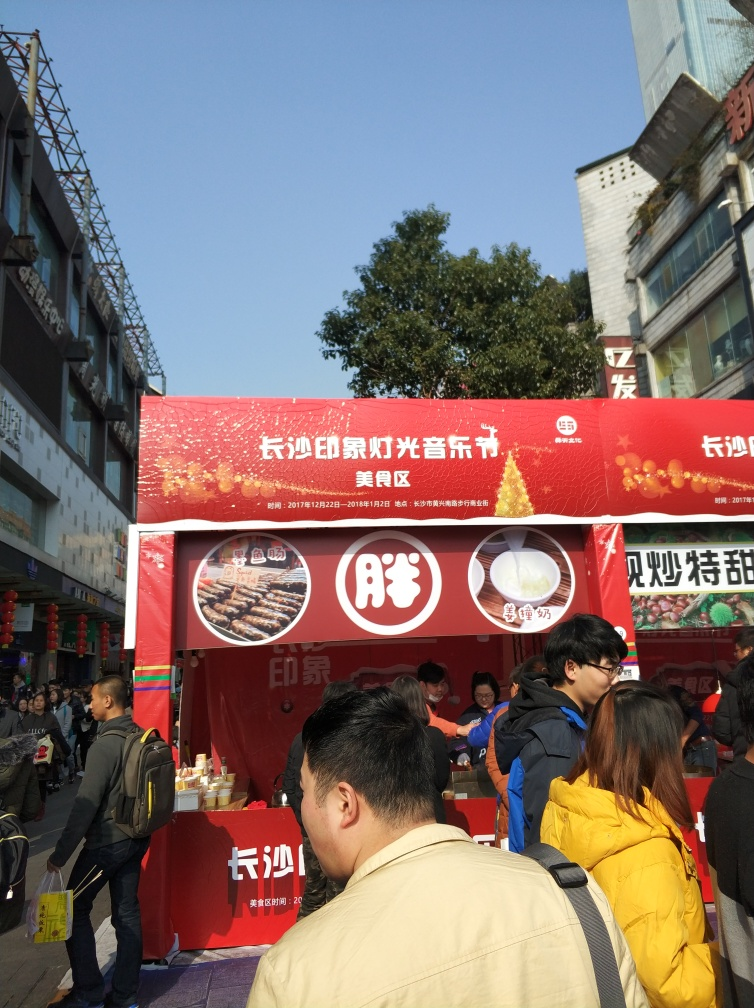Are there any indications of the time of year or season? Yes, the banner in the background mentions annual dates which could suggest the image was taken around that time, possibly indicating a seasonal or promotional event during those dates. 